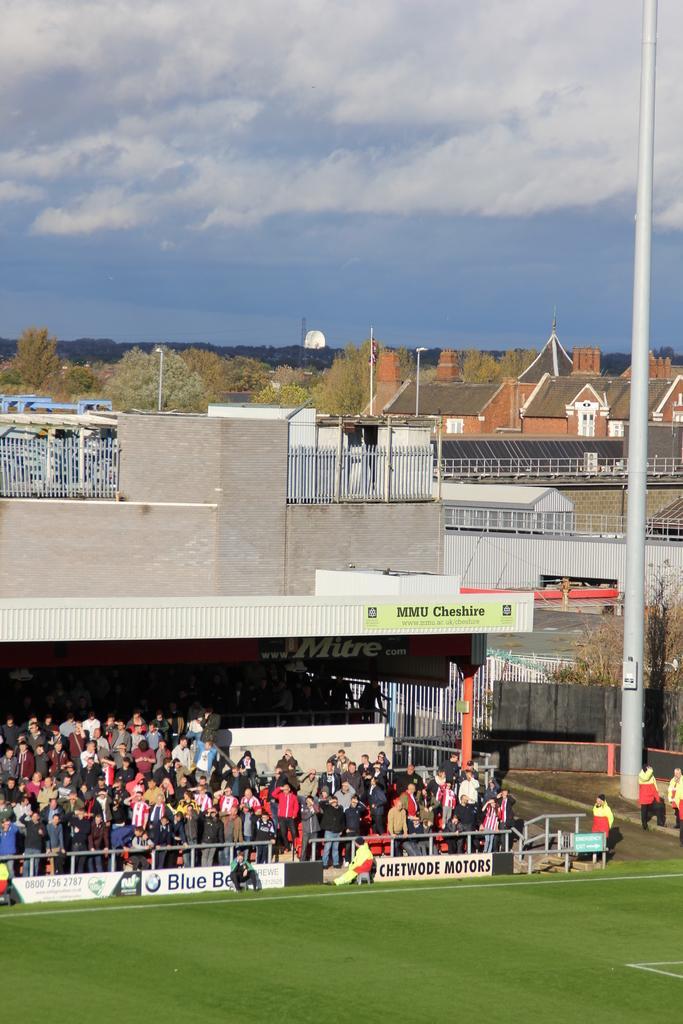Could you give a brief overview of what you see in this image? In this image we can see a group of buildings and trees. In the foreground we can see a group of persons. In front of the persons there are barriers and banners with text. On the right side, we can see a pole and the trees. At the top we can see the sky. 